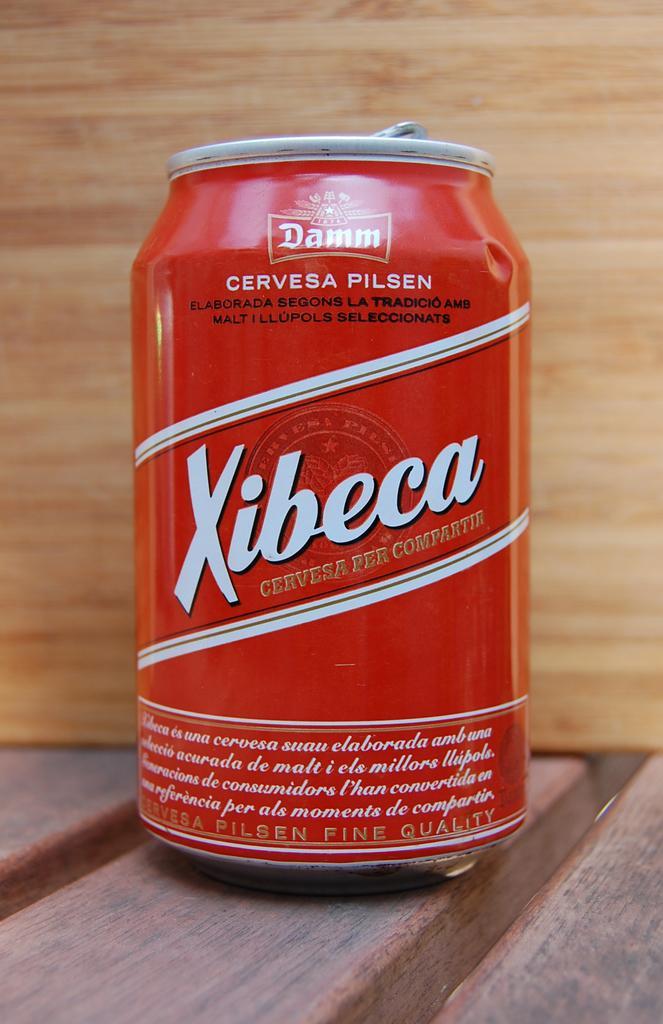Describe this image in one or two sentences. This image consists of a tin. It is in red color. On that there is "xibeca" written. 